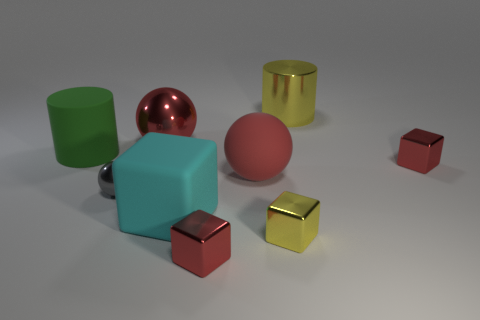How many things are either green cylinders in front of the metal cylinder or spheres that are left of the large red metallic thing?
Your response must be concise. 2. There is a yellow thing that is made of the same material as the small yellow block; what is its shape?
Offer a very short reply. Cylinder. Are there any other things of the same color as the large rubber block?
Offer a very short reply. No. What material is the other large red object that is the same shape as the red rubber object?
Your answer should be compact. Metal. How many other things are the same size as the gray sphere?
Your answer should be very brief. 3. What is the material of the tiny gray object?
Give a very brief answer. Metal. Are there more matte balls behind the small gray object than big metal objects?
Your answer should be very brief. No. Are there any small metal balls?
Your answer should be very brief. Yes. How many other objects are there of the same shape as the tiny gray metal object?
Offer a very short reply. 2. There is a metallic ball behind the green thing; does it have the same color as the large sphere that is in front of the large matte cylinder?
Offer a very short reply. Yes. 